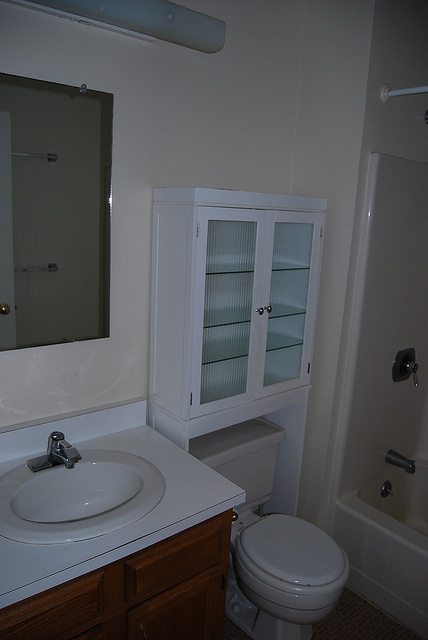Describe the objects in this image and their specific colors. I can see toilet in black and gray tones and sink in black and gray tones in this image. 